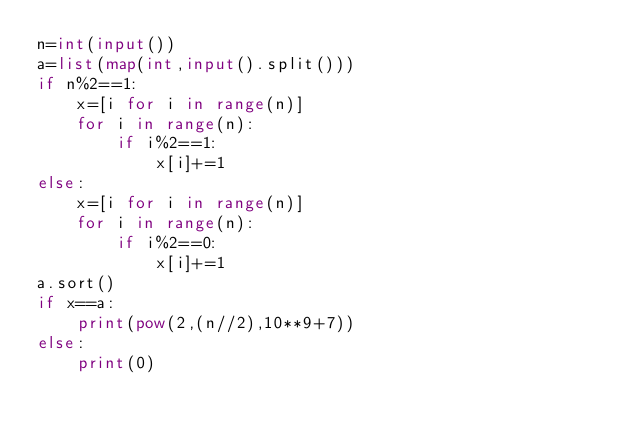Convert code to text. <code><loc_0><loc_0><loc_500><loc_500><_Python_>n=int(input())
a=list(map(int,input().split()))
if n%2==1:
    x=[i for i in range(n)]
    for i in range(n):
        if i%2==1:
            x[i]+=1
else:
    x=[i for i in range(n)]
    for i in range(n):
        if i%2==0:
            x[i]+=1
a.sort()
if x==a:
    print(pow(2,(n//2),10**9+7))
else:
    print(0)</code> 